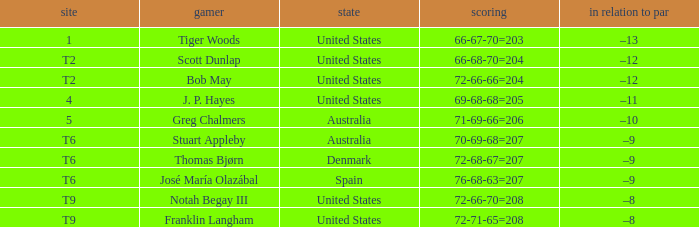What country is player thomas bjørn from? Denmark. 